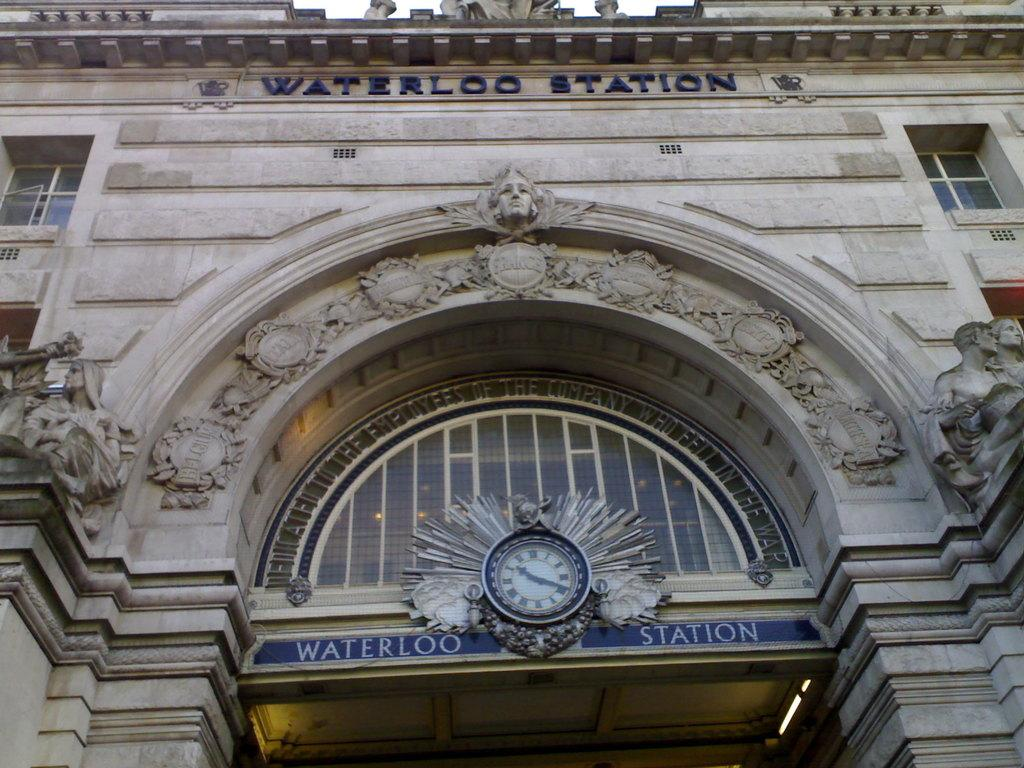<image>
Offer a succinct explanation of the picture presented. Front of Waterloo Station, stone columns leading up to ornate inlaid arch with clock at the bottom of centered half-circle window. 